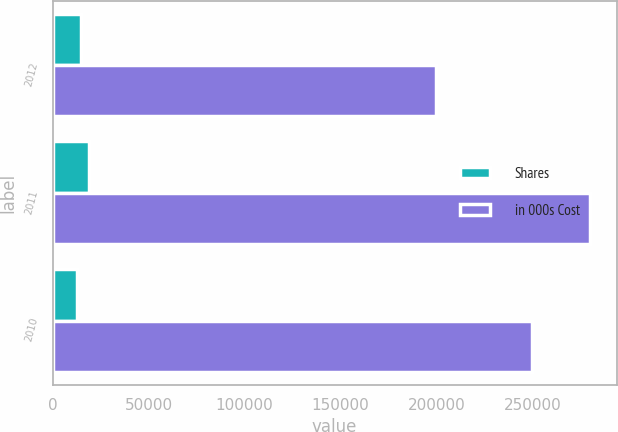Convert chart to OTSL. <chart><loc_0><loc_0><loc_500><loc_500><stacked_bar_chart><ecel><fcel>2012<fcel>2011<fcel>2010<nl><fcel>Shares<fcel>14554<fcel>18950<fcel>12786<nl><fcel>in 000s Cost<fcel>199989<fcel>279947<fcel>250003<nl></chart> 